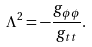Convert formula to latex. <formula><loc_0><loc_0><loc_500><loc_500>\Lambda ^ { 2 } = - \frac { g _ { \phi \phi } } { g _ { t t } } .</formula> 